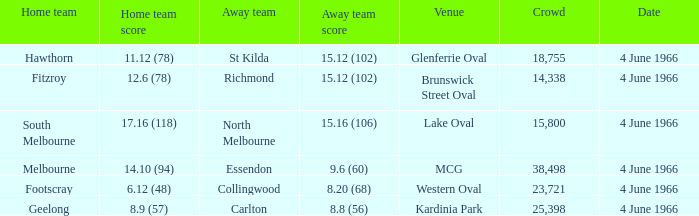What is the average crowd size of the away team who scored 9.6 (60)? 38498.0. 